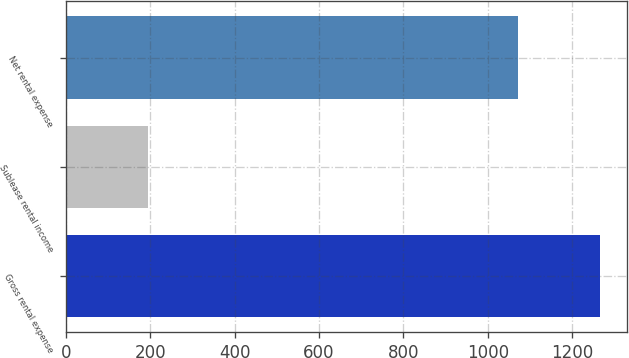Convert chart. <chart><loc_0><loc_0><loc_500><loc_500><bar_chart><fcel>Gross rental expense<fcel>Sublease rental income<fcel>Net rental expense<nl><fcel>1266<fcel>194<fcel>1072<nl></chart> 